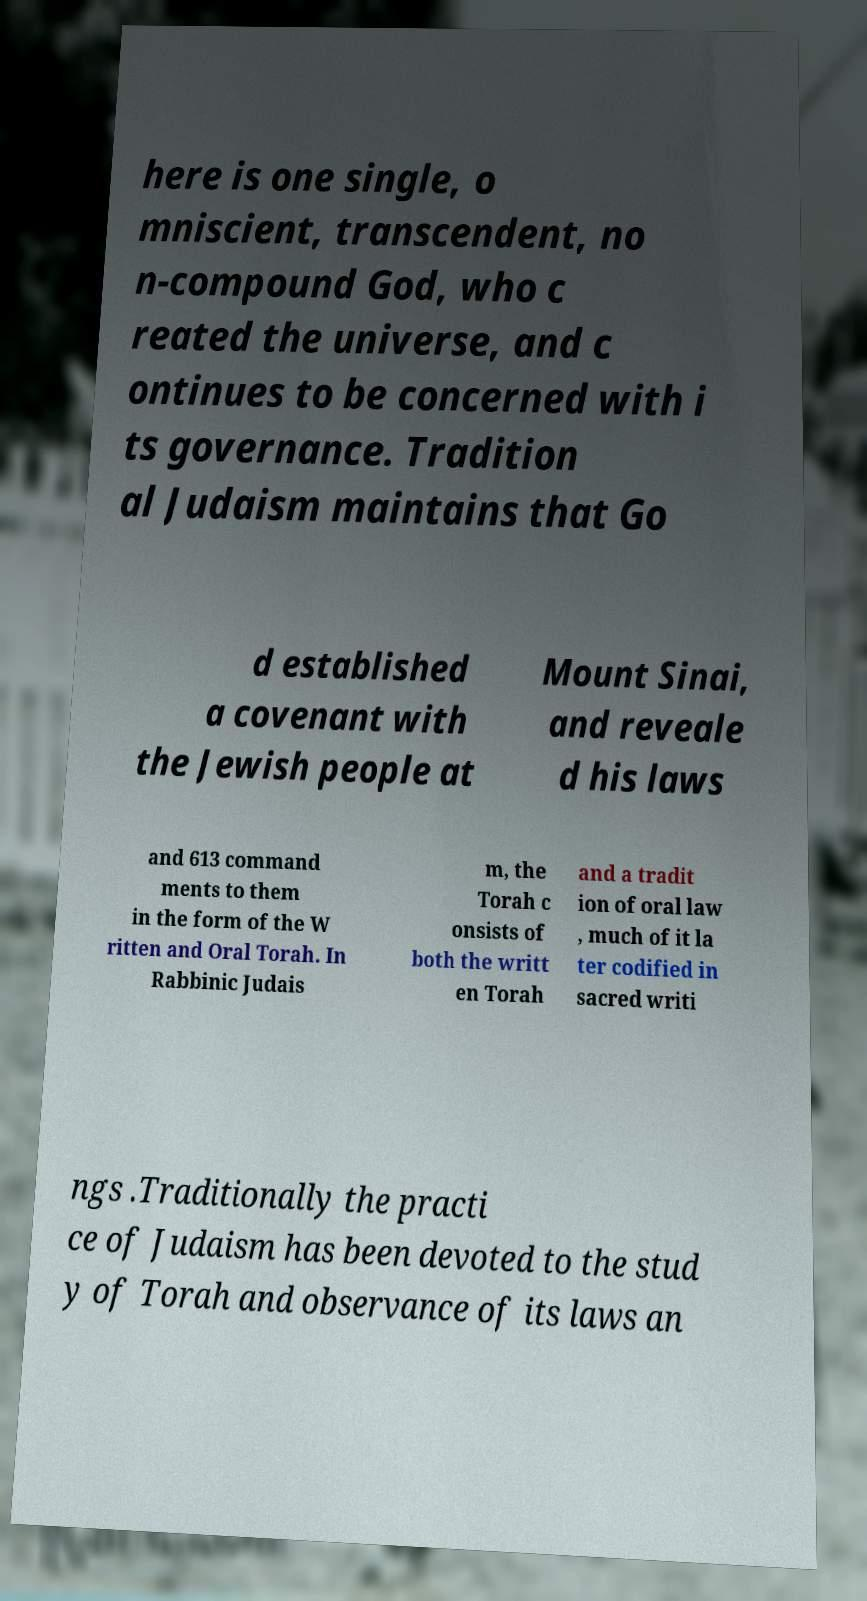What messages or text are displayed in this image? I need them in a readable, typed format. here is one single, o mniscient, transcendent, no n-compound God, who c reated the universe, and c ontinues to be concerned with i ts governance. Tradition al Judaism maintains that Go d established a covenant with the Jewish people at Mount Sinai, and reveale d his laws and 613 command ments to them in the form of the W ritten and Oral Torah. In Rabbinic Judais m, the Torah c onsists of both the writt en Torah and a tradit ion of oral law , much of it la ter codified in sacred writi ngs .Traditionally the practi ce of Judaism has been devoted to the stud y of Torah and observance of its laws an 